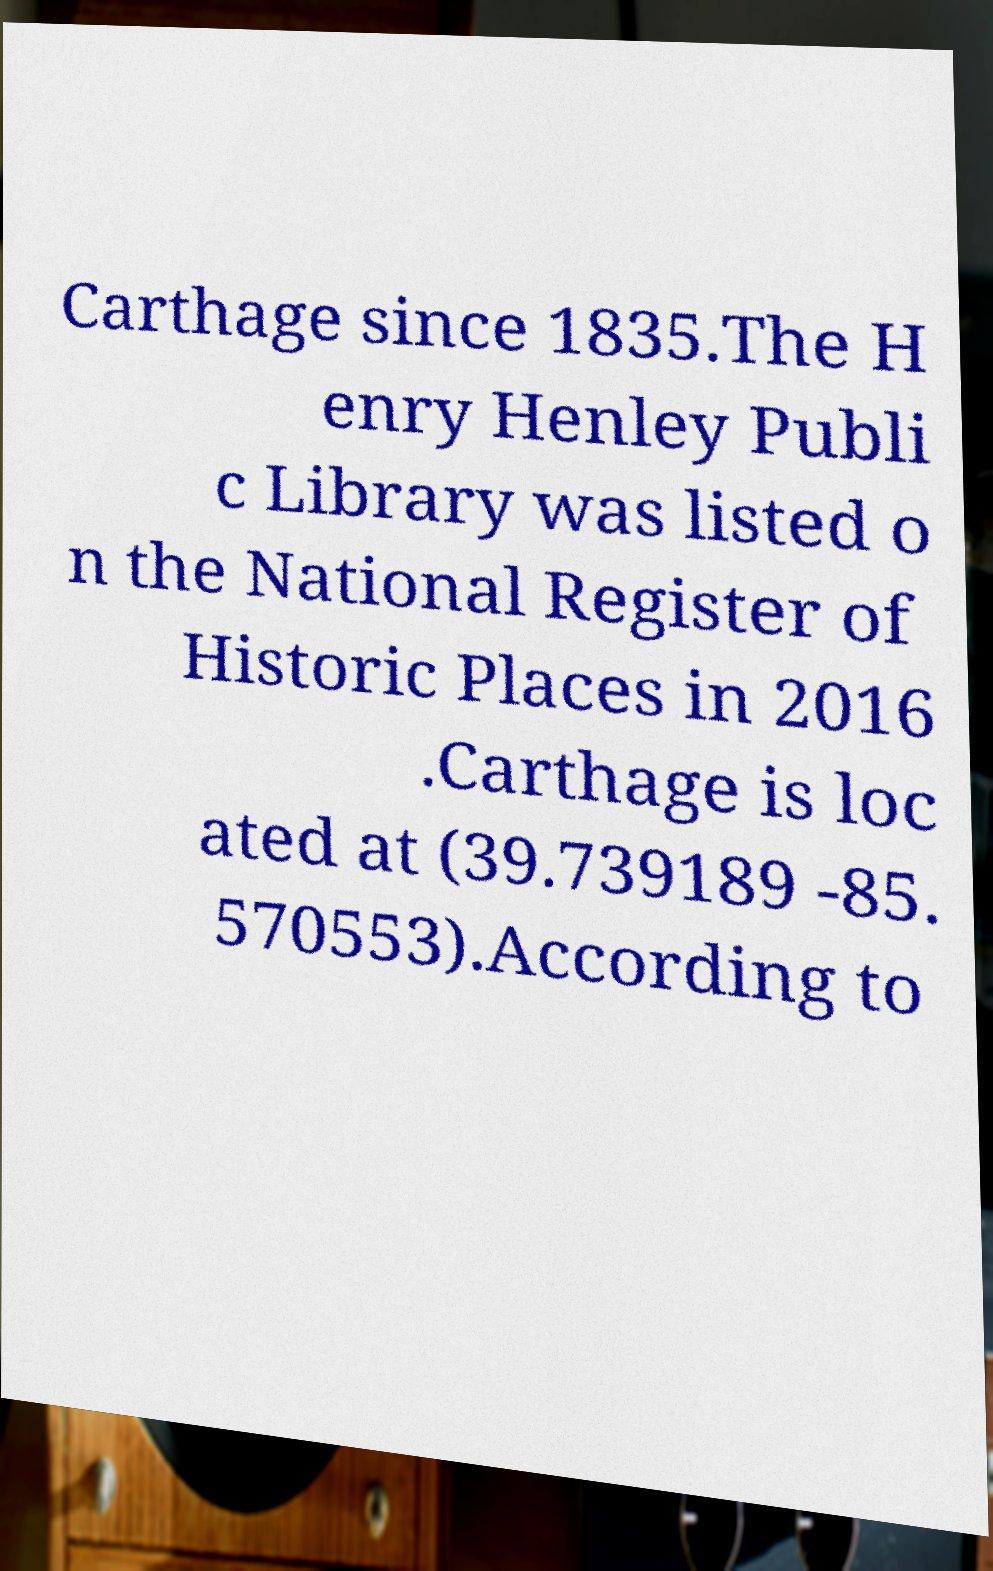What messages or text are displayed in this image? I need them in a readable, typed format. Carthage since 1835.The H enry Henley Publi c Library was listed o n the National Register of Historic Places in 2016 .Carthage is loc ated at (39.739189 -85. 570553).According to 